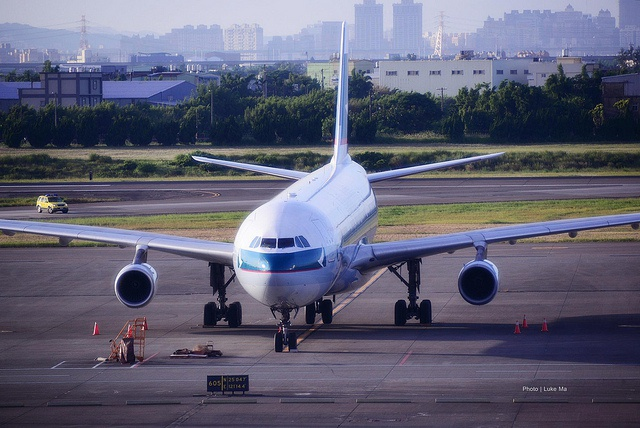Describe the objects in this image and their specific colors. I can see airplane in darkgray, black, lavender, and gray tones and car in darkgray, black, gray, navy, and khaki tones in this image. 